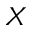<formula> <loc_0><loc_0><loc_500><loc_500>X</formula> 